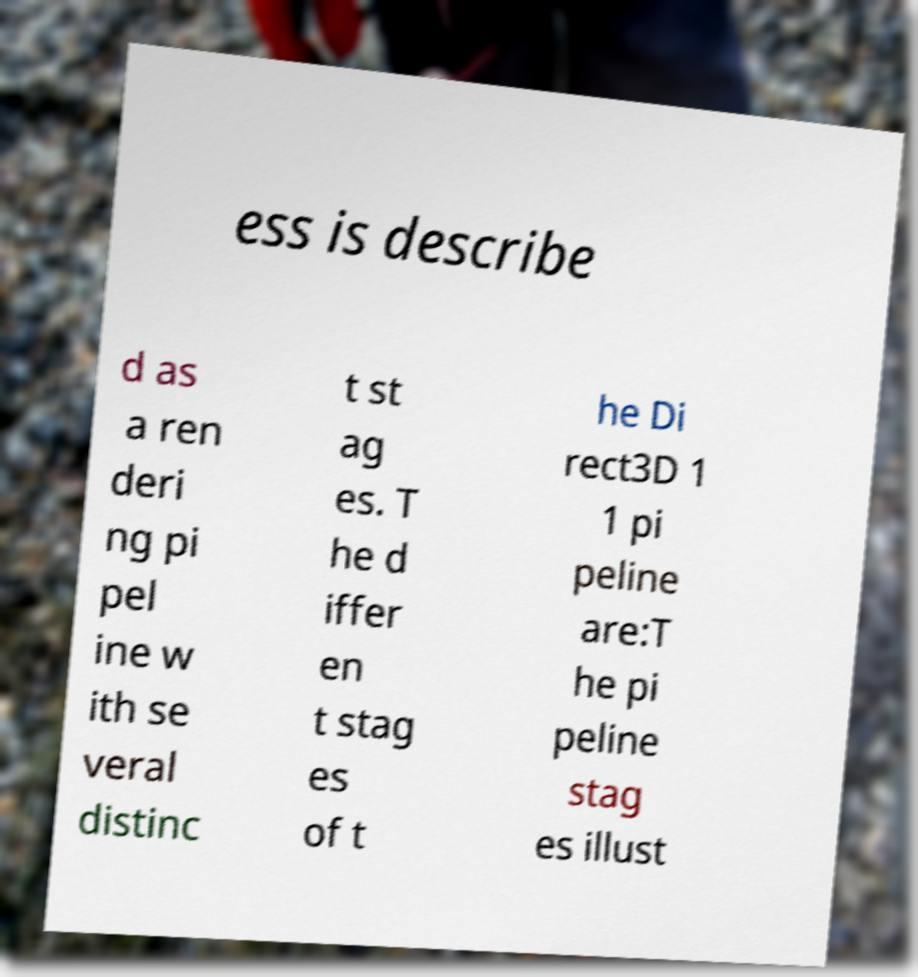Please read and relay the text visible in this image. What does it say? ess is describe d as a ren deri ng pi pel ine w ith se veral distinc t st ag es. T he d iffer en t stag es of t he Di rect3D 1 1 pi peline are:T he pi peline stag es illust 